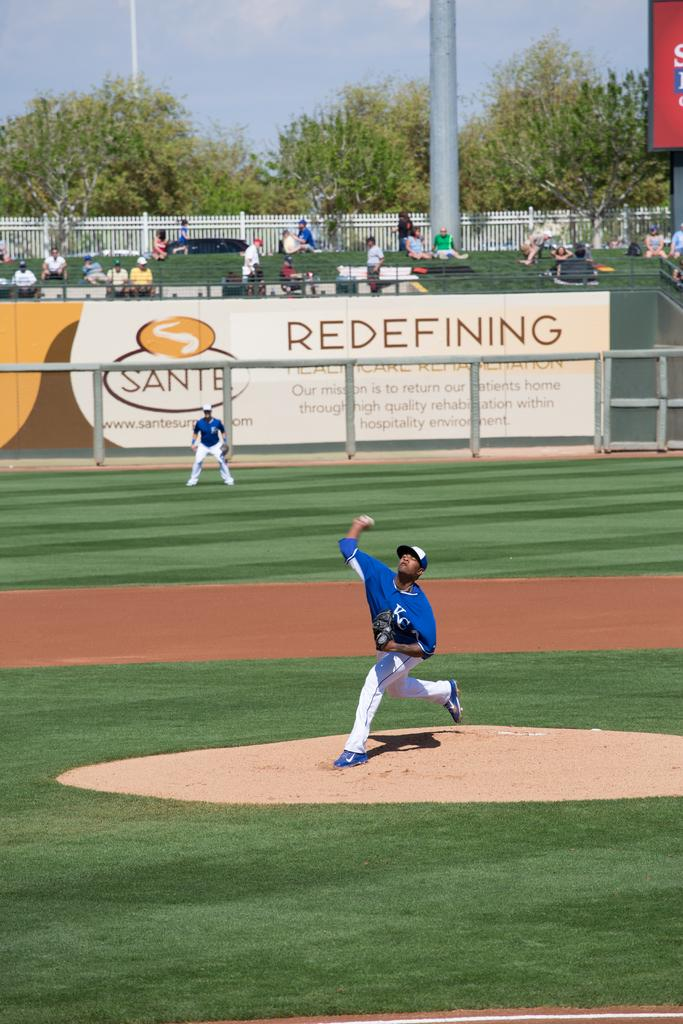<image>
Share a concise interpretation of the image provided. A baseball player throws the ball while his team mate looks on standing in front of a large advertising hoarding with SANTE and REDEFINING written on it. 